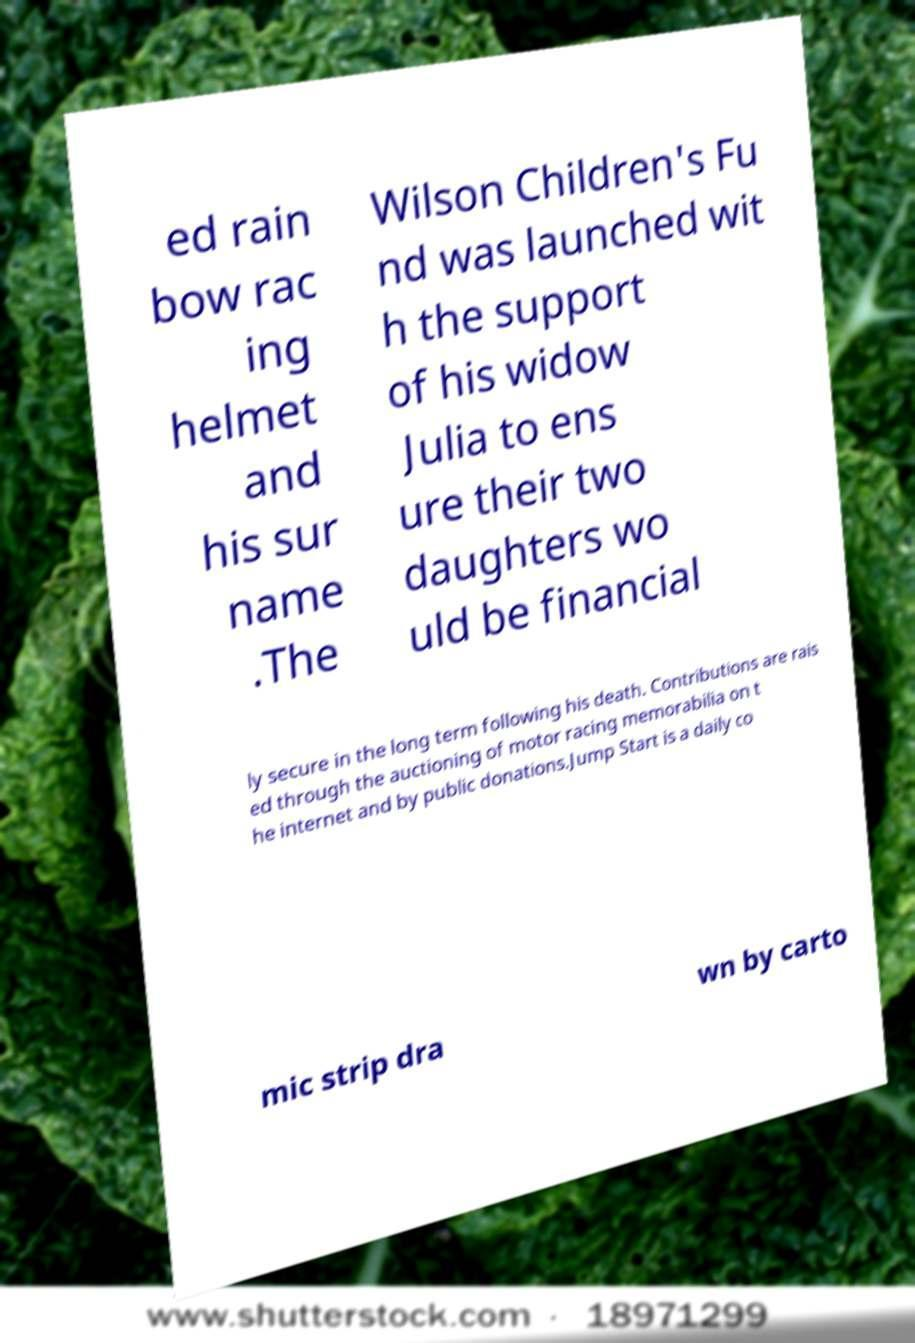For documentation purposes, I need the text within this image transcribed. Could you provide that? ed rain bow rac ing helmet and his sur name .The Wilson Children's Fu nd was launched wit h the support of his widow Julia to ens ure their two daughters wo uld be financial ly secure in the long term following his death. Contributions are rais ed through the auctioning of motor racing memorabilia on t he internet and by public donations.Jump Start is a daily co mic strip dra wn by carto 